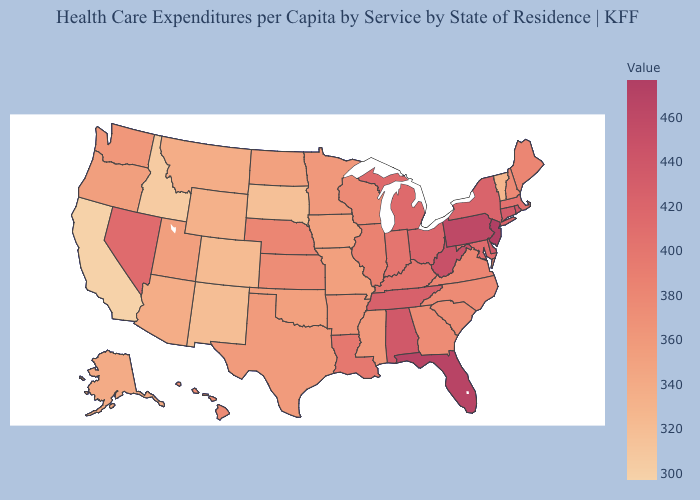Among the states that border Nebraska , does Kansas have the highest value?
Short answer required. Yes. Among the states that border Massachusetts , which have the highest value?
Give a very brief answer. Rhode Island. Among the states that border Mississippi , which have the highest value?
Concise answer only. Alabama. Among the states that border Kentucky , which have the highest value?
Answer briefly. West Virginia. Among the states that border Louisiana , does Arkansas have the highest value?
Be succinct. Yes. Among the states that border Arkansas , which have the highest value?
Answer briefly. Tennessee. 